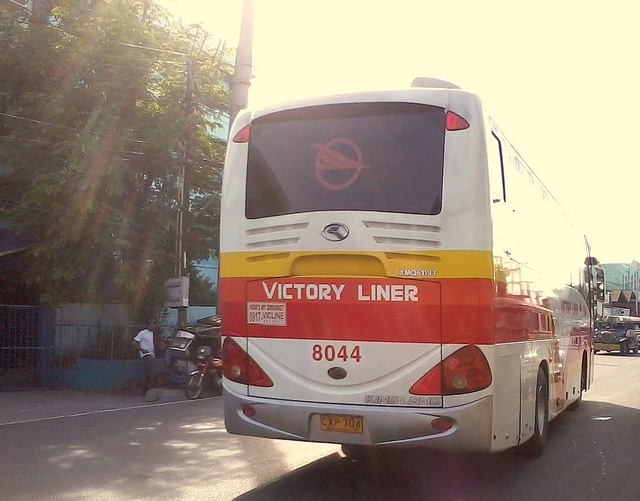Describe the objects in this image and their specific colors. I can see bus in gray, darkgray, and beige tones, truck in gray, black, and darkgray tones, motorcycle in gray and black tones, car in gray and black tones, and people in gray, darkgray, and black tones in this image. 